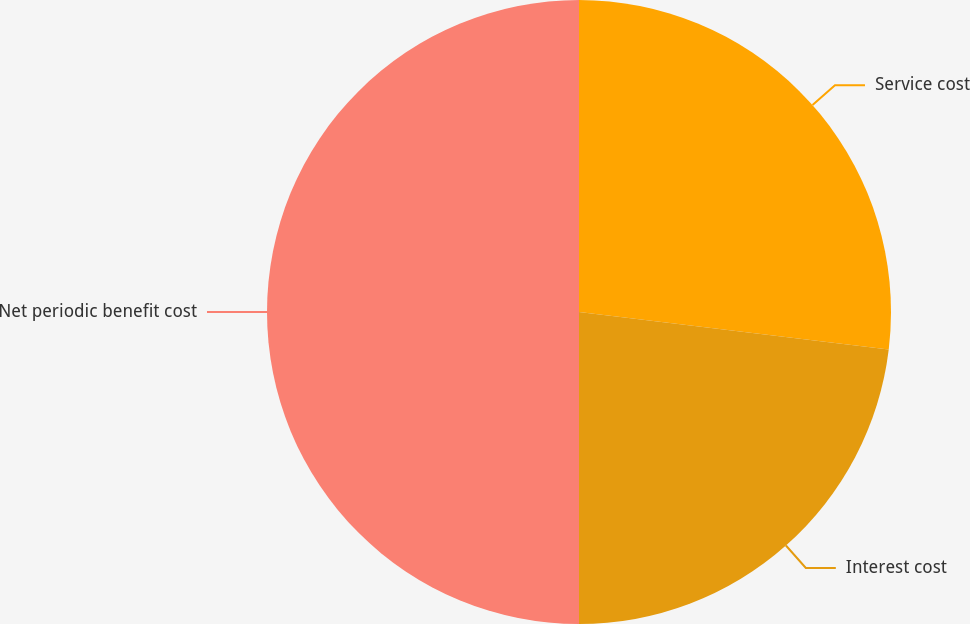Convert chart to OTSL. <chart><loc_0><loc_0><loc_500><loc_500><pie_chart><fcel>Service cost<fcel>Interest cost<fcel>Net periodic benefit cost<nl><fcel>26.92%<fcel>23.08%<fcel>50.0%<nl></chart> 